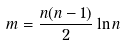Convert formula to latex. <formula><loc_0><loc_0><loc_500><loc_500>m = { \frac { n ( n - 1 ) } { 2 } } \ln n</formula> 